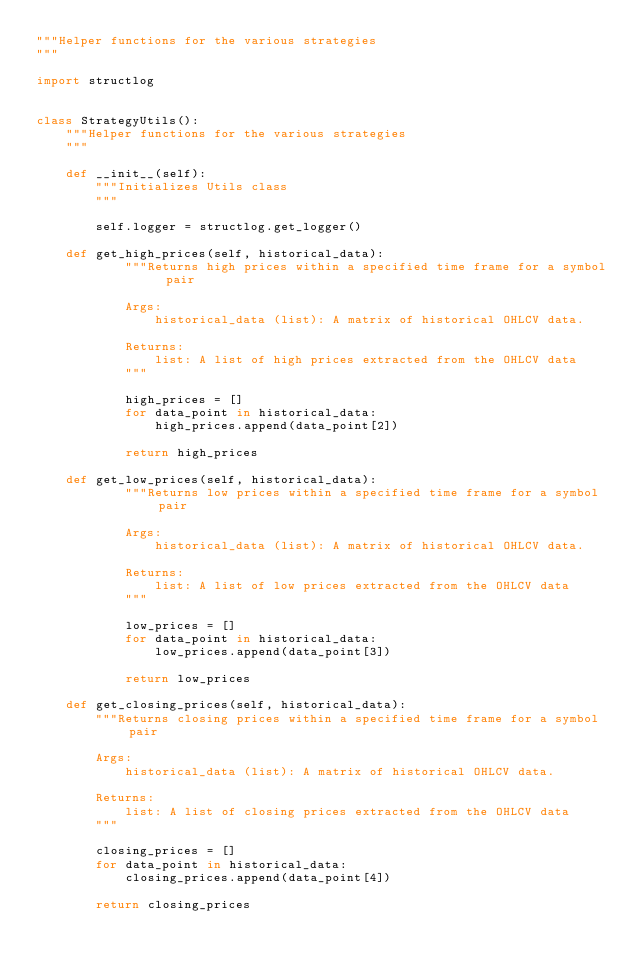<code> <loc_0><loc_0><loc_500><loc_500><_Python_>"""Helper functions for the various strategies
"""

import structlog


class StrategyUtils():
    """Helper functions for the various strategies
    """

    def __init__(self):
        """Initializes Utils class
        """

        self.logger = structlog.get_logger()

    def get_high_prices(self, historical_data):
            """Returns high prices within a specified time frame for a symbol pair

            Args:
                historical_data (list): A matrix of historical OHLCV data.

            Returns:
                list: A list of high prices extracted from the OHLCV data
            """

            high_prices = []
            for data_point in historical_data:
                high_prices.append(data_point[2])

            return high_prices

    def get_low_prices(self, historical_data):
            """Returns low prices within a specified time frame for a symbol pair

            Args:
                historical_data (list): A matrix of historical OHLCV data.

            Returns:
                list: A list of low prices extracted from the OHLCV data
            """

            low_prices = []
            for data_point in historical_data:
                low_prices.append(data_point[3])

            return low_prices

    def get_closing_prices(self, historical_data):
        """Returns closing prices within a specified time frame for a symbol pair

        Args:
            historical_data (list): A matrix of historical OHLCV data.

        Returns:
            list: A list of closing prices extracted from the OHLCV data
        """

        closing_prices = []
        for data_point in historical_data:
            closing_prices.append(data_point[4])

        return closing_prices
</code> 